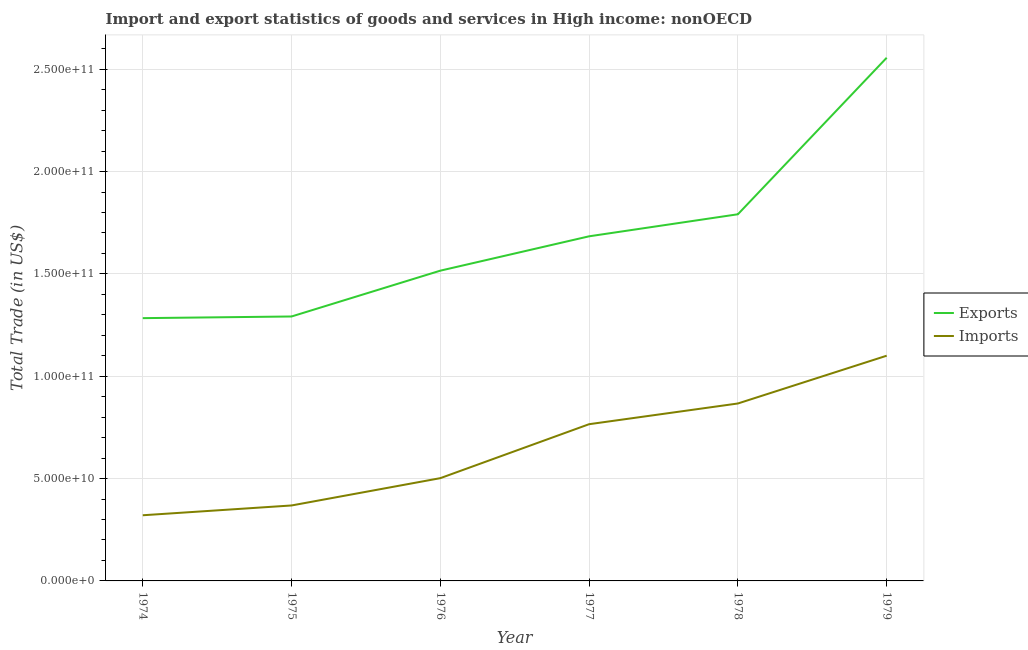How many different coloured lines are there?
Make the answer very short. 2. Does the line corresponding to imports of goods and services intersect with the line corresponding to export of goods and services?
Give a very brief answer. No. What is the export of goods and services in 1974?
Make the answer very short. 1.28e+11. Across all years, what is the maximum imports of goods and services?
Keep it short and to the point. 1.10e+11. Across all years, what is the minimum export of goods and services?
Your answer should be very brief. 1.28e+11. In which year was the imports of goods and services maximum?
Keep it short and to the point. 1979. In which year was the export of goods and services minimum?
Your response must be concise. 1974. What is the total export of goods and services in the graph?
Ensure brevity in your answer.  1.01e+12. What is the difference between the export of goods and services in 1974 and that in 1976?
Keep it short and to the point. -2.32e+1. What is the difference between the imports of goods and services in 1979 and the export of goods and services in 1976?
Offer a very short reply. -4.15e+1. What is the average imports of goods and services per year?
Your response must be concise. 6.54e+1. In the year 1977, what is the difference between the imports of goods and services and export of goods and services?
Give a very brief answer. -9.18e+1. What is the ratio of the imports of goods and services in 1978 to that in 1979?
Your response must be concise. 0.79. Is the export of goods and services in 1974 less than that in 1975?
Offer a terse response. Yes. Is the difference between the export of goods and services in 1974 and 1975 greater than the difference between the imports of goods and services in 1974 and 1975?
Offer a very short reply. Yes. What is the difference between the highest and the second highest export of goods and services?
Keep it short and to the point. 7.65e+1. What is the difference between the highest and the lowest export of goods and services?
Provide a succinct answer. 1.27e+11. In how many years, is the imports of goods and services greater than the average imports of goods and services taken over all years?
Ensure brevity in your answer.  3. Is the sum of the export of goods and services in 1974 and 1976 greater than the maximum imports of goods and services across all years?
Give a very brief answer. Yes. Does the imports of goods and services monotonically increase over the years?
Provide a succinct answer. Yes. Is the export of goods and services strictly less than the imports of goods and services over the years?
Offer a terse response. No. How many years are there in the graph?
Ensure brevity in your answer.  6. Are the values on the major ticks of Y-axis written in scientific E-notation?
Keep it short and to the point. Yes. Does the graph contain any zero values?
Ensure brevity in your answer.  No. Does the graph contain grids?
Offer a terse response. Yes. Where does the legend appear in the graph?
Offer a terse response. Center right. How many legend labels are there?
Your response must be concise. 2. What is the title of the graph?
Your answer should be very brief. Import and export statistics of goods and services in High income: nonOECD. What is the label or title of the X-axis?
Keep it short and to the point. Year. What is the label or title of the Y-axis?
Your answer should be compact. Total Trade (in US$). What is the Total Trade (in US$) in Exports in 1974?
Make the answer very short. 1.28e+11. What is the Total Trade (in US$) of Imports in 1974?
Provide a short and direct response. 3.21e+1. What is the Total Trade (in US$) in Exports in 1975?
Ensure brevity in your answer.  1.29e+11. What is the Total Trade (in US$) in Imports in 1975?
Offer a terse response. 3.69e+1. What is the Total Trade (in US$) of Exports in 1976?
Your answer should be compact. 1.52e+11. What is the Total Trade (in US$) in Imports in 1976?
Your answer should be compact. 5.02e+1. What is the Total Trade (in US$) of Exports in 1977?
Keep it short and to the point. 1.68e+11. What is the Total Trade (in US$) of Imports in 1977?
Make the answer very short. 7.66e+1. What is the Total Trade (in US$) in Exports in 1978?
Offer a very short reply. 1.79e+11. What is the Total Trade (in US$) of Imports in 1978?
Provide a succinct answer. 8.67e+1. What is the Total Trade (in US$) in Exports in 1979?
Your response must be concise. 2.56e+11. What is the Total Trade (in US$) in Imports in 1979?
Your response must be concise. 1.10e+11. Across all years, what is the maximum Total Trade (in US$) in Exports?
Your response must be concise. 2.56e+11. Across all years, what is the maximum Total Trade (in US$) in Imports?
Your answer should be very brief. 1.10e+11. Across all years, what is the minimum Total Trade (in US$) in Exports?
Offer a terse response. 1.28e+11. Across all years, what is the minimum Total Trade (in US$) of Imports?
Make the answer very short. 3.21e+1. What is the total Total Trade (in US$) in Exports in the graph?
Your response must be concise. 1.01e+12. What is the total Total Trade (in US$) in Imports in the graph?
Your response must be concise. 3.92e+11. What is the difference between the Total Trade (in US$) in Exports in 1974 and that in 1975?
Provide a short and direct response. -8.14e+08. What is the difference between the Total Trade (in US$) of Imports in 1974 and that in 1975?
Provide a succinct answer. -4.78e+09. What is the difference between the Total Trade (in US$) in Exports in 1974 and that in 1976?
Your response must be concise. -2.32e+1. What is the difference between the Total Trade (in US$) of Imports in 1974 and that in 1976?
Ensure brevity in your answer.  -1.81e+1. What is the difference between the Total Trade (in US$) in Exports in 1974 and that in 1977?
Offer a terse response. -4.00e+1. What is the difference between the Total Trade (in US$) in Imports in 1974 and that in 1977?
Ensure brevity in your answer.  -4.45e+1. What is the difference between the Total Trade (in US$) of Exports in 1974 and that in 1978?
Make the answer very short. -5.08e+1. What is the difference between the Total Trade (in US$) of Imports in 1974 and that in 1978?
Your answer should be compact. -5.46e+1. What is the difference between the Total Trade (in US$) of Exports in 1974 and that in 1979?
Offer a terse response. -1.27e+11. What is the difference between the Total Trade (in US$) in Imports in 1974 and that in 1979?
Make the answer very short. -7.80e+1. What is the difference between the Total Trade (in US$) in Exports in 1975 and that in 1976?
Provide a succinct answer. -2.24e+1. What is the difference between the Total Trade (in US$) of Imports in 1975 and that in 1976?
Your answer should be very brief. -1.33e+1. What is the difference between the Total Trade (in US$) of Exports in 1975 and that in 1977?
Make the answer very short. -3.92e+1. What is the difference between the Total Trade (in US$) of Imports in 1975 and that in 1977?
Give a very brief answer. -3.97e+1. What is the difference between the Total Trade (in US$) of Exports in 1975 and that in 1978?
Offer a terse response. -4.99e+1. What is the difference between the Total Trade (in US$) of Imports in 1975 and that in 1978?
Your answer should be compact. -4.98e+1. What is the difference between the Total Trade (in US$) in Exports in 1975 and that in 1979?
Make the answer very short. -1.26e+11. What is the difference between the Total Trade (in US$) in Imports in 1975 and that in 1979?
Ensure brevity in your answer.  -7.32e+1. What is the difference between the Total Trade (in US$) of Exports in 1976 and that in 1977?
Ensure brevity in your answer.  -1.68e+1. What is the difference between the Total Trade (in US$) of Imports in 1976 and that in 1977?
Keep it short and to the point. -2.64e+1. What is the difference between the Total Trade (in US$) of Exports in 1976 and that in 1978?
Your answer should be very brief. -2.76e+1. What is the difference between the Total Trade (in US$) of Imports in 1976 and that in 1978?
Provide a succinct answer. -3.65e+1. What is the difference between the Total Trade (in US$) of Exports in 1976 and that in 1979?
Offer a very short reply. -1.04e+11. What is the difference between the Total Trade (in US$) in Imports in 1976 and that in 1979?
Offer a terse response. -5.98e+1. What is the difference between the Total Trade (in US$) in Exports in 1977 and that in 1978?
Offer a terse response. -1.08e+1. What is the difference between the Total Trade (in US$) in Imports in 1977 and that in 1978?
Keep it short and to the point. -1.01e+1. What is the difference between the Total Trade (in US$) of Exports in 1977 and that in 1979?
Your response must be concise. -8.72e+1. What is the difference between the Total Trade (in US$) in Imports in 1977 and that in 1979?
Provide a succinct answer. -3.35e+1. What is the difference between the Total Trade (in US$) of Exports in 1978 and that in 1979?
Offer a terse response. -7.65e+1. What is the difference between the Total Trade (in US$) in Imports in 1978 and that in 1979?
Your response must be concise. -2.33e+1. What is the difference between the Total Trade (in US$) of Exports in 1974 and the Total Trade (in US$) of Imports in 1975?
Keep it short and to the point. 9.15e+1. What is the difference between the Total Trade (in US$) of Exports in 1974 and the Total Trade (in US$) of Imports in 1976?
Your answer should be compact. 7.82e+1. What is the difference between the Total Trade (in US$) in Exports in 1974 and the Total Trade (in US$) in Imports in 1977?
Your response must be concise. 5.18e+1. What is the difference between the Total Trade (in US$) in Exports in 1974 and the Total Trade (in US$) in Imports in 1978?
Your answer should be compact. 4.17e+1. What is the difference between the Total Trade (in US$) in Exports in 1974 and the Total Trade (in US$) in Imports in 1979?
Your response must be concise. 1.84e+1. What is the difference between the Total Trade (in US$) of Exports in 1975 and the Total Trade (in US$) of Imports in 1976?
Your answer should be very brief. 7.90e+1. What is the difference between the Total Trade (in US$) of Exports in 1975 and the Total Trade (in US$) of Imports in 1977?
Your response must be concise. 5.26e+1. What is the difference between the Total Trade (in US$) in Exports in 1975 and the Total Trade (in US$) in Imports in 1978?
Give a very brief answer. 4.25e+1. What is the difference between the Total Trade (in US$) in Exports in 1975 and the Total Trade (in US$) in Imports in 1979?
Provide a succinct answer. 1.92e+1. What is the difference between the Total Trade (in US$) of Exports in 1976 and the Total Trade (in US$) of Imports in 1977?
Offer a terse response. 7.50e+1. What is the difference between the Total Trade (in US$) in Exports in 1976 and the Total Trade (in US$) in Imports in 1978?
Give a very brief answer. 6.49e+1. What is the difference between the Total Trade (in US$) of Exports in 1976 and the Total Trade (in US$) of Imports in 1979?
Offer a terse response. 4.15e+1. What is the difference between the Total Trade (in US$) in Exports in 1977 and the Total Trade (in US$) in Imports in 1978?
Keep it short and to the point. 8.17e+1. What is the difference between the Total Trade (in US$) in Exports in 1977 and the Total Trade (in US$) in Imports in 1979?
Your response must be concise. 5.83e+1. What is the difference between the Total Trade (in US$) of Exports in 1978 and the Total Trade (in US$) of Imports in 1979?
Make the answer very short. 6.91e+1. What is the average Total Trade (in US$) in Exports per year?
Provide a short and direct response. 1.69e+11. What is the average Total Trade (in US$) of Imports per year?
Your answer should be very brief. 6.54e+1. In the year 1974, what is the difference between the Total Trade (in US$) of Exports and Total Trade (in US$) of Imports?
Your response must be concise. 9.63e+1. In the year 1975, what is the difference between the Total Trade (in US$) of Exports and Total Trade (in US$) of Imports?
Your answer should be very brief. 9.23e+1. In the year 1976, what is the difference between the Total Trade (in US$) of Exports and Total Trade (in US$) of Imports?
Ensure brevity in your answer.  1.01e+11. In the year 1977, what is the difference between the Total Trade (in US$) of Exports and Total Trade (in US$) of Imports?
Provide a succinct answer. 9.18e+1. In the year 1978, what is the difference between the Total Trade (in US$) of Exports and Total Trade (in US$) of Imports?
Your response must be concise. 9.25e+1. In the year 1979, what is the difference between the Total Trade (in US$) in Exports and Total Trade (in US$) in Imports?
Offer a very short reply. 1.46e+11. What is the ratio of the Total Trade (in US$) of Imports in 1974 to that in 1975?
Ensure brevity in your answer.  0.87. What is the ratio of the Total Trade (in US$) of Exports in 1974 to that in 1976?
Make the answer very short. 0.85. What is the ratio of the Total Trade (in US$) in Imports in 1974 to that in 1976?
Provide a short and direct response. 0.64. What is the ratio of the Total Trade (in US$) in Exports in 1974 to that in 1977?
Provide a short and direct response. 0.76. What is the ratio of the Total Trade (in US$) of Imports in 1974 to that in 1977?
Make the answer very short. 0.42. What is the ratio of the Total Trade (in US$) of Exports in 1974 to that in 1978?
Provide a short and direct response. 0.72. What is the ratio of the Total Trade (in US$) of Imports in 1974 to that in 1978?
Keep it short and to the point. 0.37. What is the ratio of the Total Trade (in US$) in Exports in 1974 to that in 1979?
Give a very brief answer. 0.5. What is the ratio of the Total Trade (in US$) of Imports in 1974 to that in 1979?
Provide a short and direct response. 0.29. What is the ratio of the Total Trade (in US$) in Exports in 1975 to that in 1976?
Your answer should be very brief. 0.85. What is the ratio of the Total Trade (in US$) of Imports in 1975 to that in 1976?
Make the answer very short. 0.73. What is the ratio of the Total Trade (in US$) of Exports in 1975 to that in 1977?
Keep it short and to the point. 0.77. What is the ratio of the Total Trade (in US$) of Imports in 1975 to that in 1977?
Your answer should be compact. 0.48. What is the ratio of the Total Trade (in US$) of Exports in 1975 to that in 1978?
Offer a very short reply. 0.72. What is the ratio of the Total Trade (in US$) of Imports in 1975 to that in 1978?
Your answer should be compact. 0.43. What is the ratio of the Total Trade (in US$) of Exports in 1975 to that in 1979?
Your answer should be compact. 0.51. What is the ratio of the Total Trade (in US$) of Imports in 1975 to that in 1979?
Ensure brevity in your answer.  0.34. What is the ratio of the Total Trade (in US$) of Exports in 1976 to that in 1977?
Make the answer very short. 0.9. What is the ratio of the Total Trade (in US$) of Imports in 1976 to that in 1977?
Offer a very short reply. 0.66. What is the ratio of the Total Trade (in US$) in Exports in 1976 to that in 1978?
Offer a terse response. 0.85. What is the ratio of the Total Trade (in US$) of Imports in 1976 to that in 1978?
Your answer should be compact. 0.58. What is the ratio of the Total Trade (in US$) of Exports in 1976 to that in 1979?
Offer a very short reply. 0.59. What is the ratio of the Total Trade (in US$) of Imports in 1976 to that in 1979?
Your answer should be compact. 0.46. What is the ratio of the Total Trade (in US$) in Exports in 1977 to that in 1978?
Your answer should be compact. 0.94. What is the ratio of the Total Trade (in US$) of Imports in 1977 to that in 1978?
Make the answer very short. 0.88. What is the ratio of the Total Trade (in US$) of Exports in 1977 to that in 1979?
Keep it short and to the point. 0.66. What is the ratio of the Total Trade (in US$) in Imports in 1977 to that in 1979?
Give a very brief answer. 0.7. What is the ratio of the Total Trade (in US$) of Exports in 1978 to that in 1979?
Offer a very short reply. 0.7. What is the ratio of the Total Trade (in US$) of Imports in 1978 to that in 1979?
Your answer should be compact. 0.79. What is the difference between the highest and the second highest Total Trade (in US$) of Exports?
Ensure brevity in your answer.  7.65e+1. What is the difference between the highest and the second highest Total Trade (in US$) in Imports?
Offer a very short reply. 2.33e+1. What is the difference between the highest and the lowest Total Trade (in US$) of Exports?
Keep it short and to the point. 1.27e+11. What is the difference between the highest and the lowest Total Trade (in US$) in Imports?
Provide a succinct answer. 7.80e+1. 